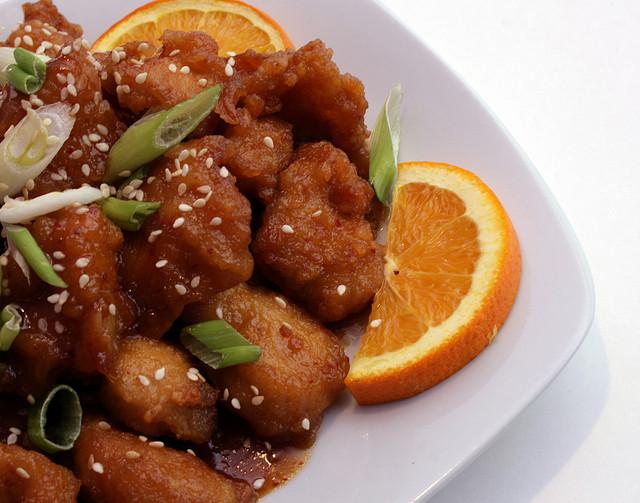Is this Chinese food?
Concise answer only. Yes. What is the green stuff?
Short answer required. Chives. What is this food?
Quick response, please. Sesame chicken. What is the green vegetable on the plate?
Answer briefly. Chives. From what culture is this cuisine derived?
Short answer required. Chinese. What are the three main ingredients on the plate?
Concise answer only. Chicken, onion, sesame. What kind of seafood is on top of the orange?
Concise answer only. Shrimp. What color is the plate?
Quick response, please. White. Does the chicken appear to have specks of white rice on it?
Give a very brief answer. No. 